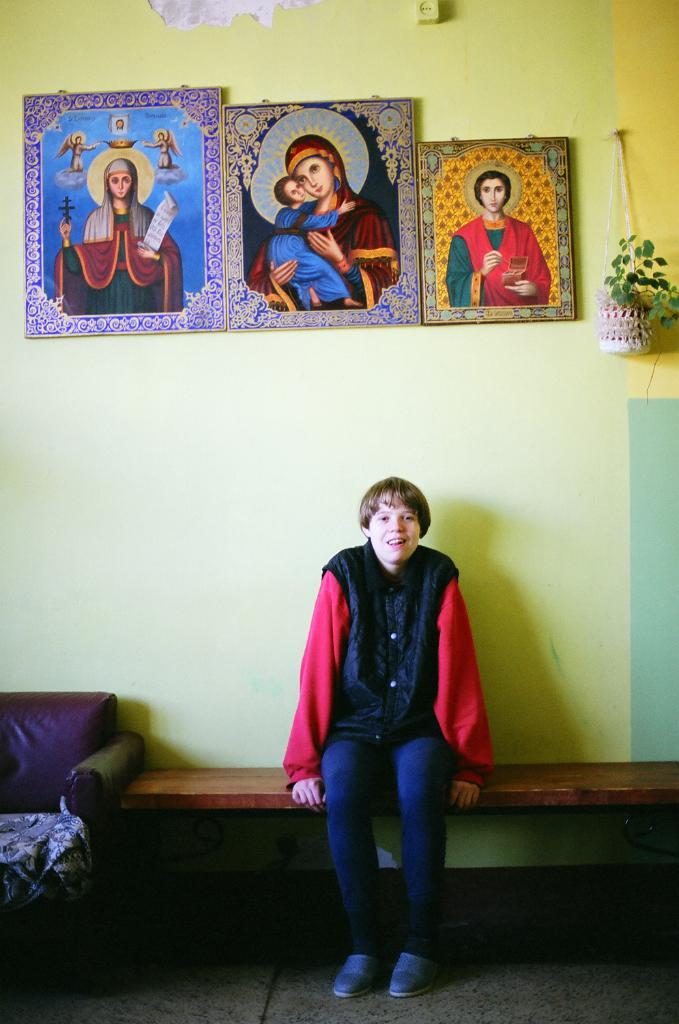What type of furniture is present in the image? There is a chair in the image. What is the person in the image doing? There is a person sitting on a bench in the image. What decorative items can be seen in the image? There are photo frames in the image. What type of background is visible in the image? There is a wall in the image. What type of plant is present in the image? There is a plant in the image. How many canvases are hanging on the wall in the image? There is no mention of canvases in the provided facts, so we cannot determine the number of canvases in the image. What is the amount of gold present in the image? There is no mention of gold in the provided facts, so we cannot determine the amount of gold in the image. 